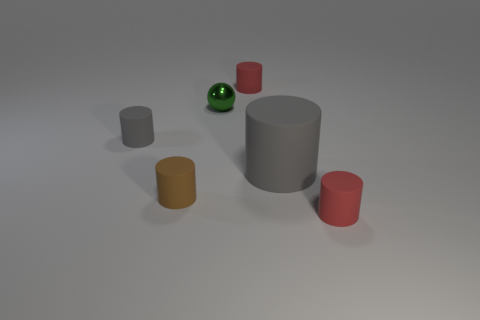Does the brown thing have the same size as the red matte cylinder in front of the tiny gray matte cylinder?
Your response must be concise. Yes. Does the gray object on the right side of the brown cylinder have the same size as the brown object?
Provide a short and direct response. No. How many other objects are there of the same material as the large gray object?
Provide a succinct answer. 4. Are there an equal number of small shiny balls to the left of the green sphere and big gray rubber cylinders that are on the left side of the brown matte cylinder?
Your answer should be compact. Yes. There is a sphere on the left side of the rubber object that is right of the gray rubber cylinder right of the tiny brown thing; what is its color?
Your answer should be very brief. Green. What shape is the tiny green thing that is behind the small gray matte thing?
Your response must be concise. Sphere. There is a tiny gray thing that is made of the same material as the large gray cylinder; what shape is it?
Your answer should be very brief. Cylinder. Is there anything else that is the same shape as the tiny gray object?
Give a very brief answer. Yes. There is a large rubber object; what number of tiny spheres are left of it?
Ensure brevity in your answer.  1. Are there the same number of small red matte objects left of the brown cylinder and big green rubber cubes?
Your answer should be very brief. Yes. 